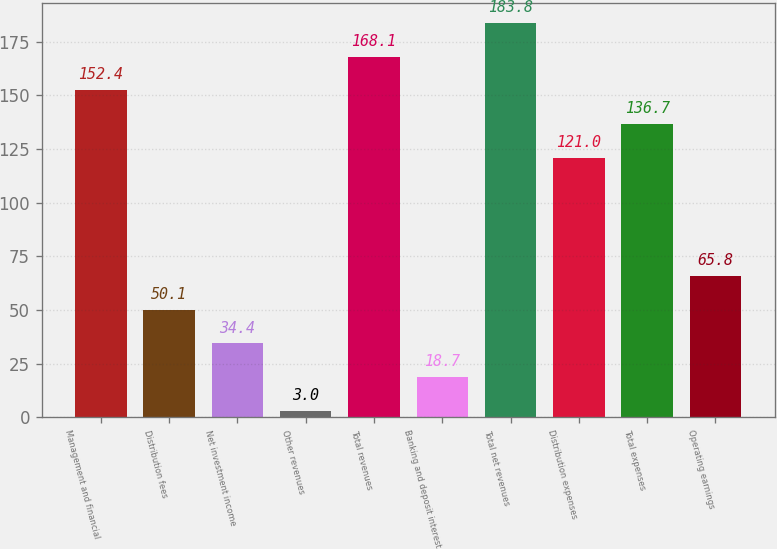Convert chart. <chart><loc_0><loc_0><loc_500><loc_500><bar_chart><fcel>Management and financial<fcel>Distribution fees<fcel>Net investment income<fcel>Other revenues<fcel>Total revenues<fcel>Banking and deposit interest<fcel>Total net revenues<fcel>Distribution expenses<fcel>Total expenses<fcel>Operating earnings<nl><fcel>152.4<fcel>50.1<fcel>34.4<fcel>3<fcel>168.1<fcel>18.7<fcel>183.8<fcel>121<fcel>136.7<fcel>65.8<nl></chart> 